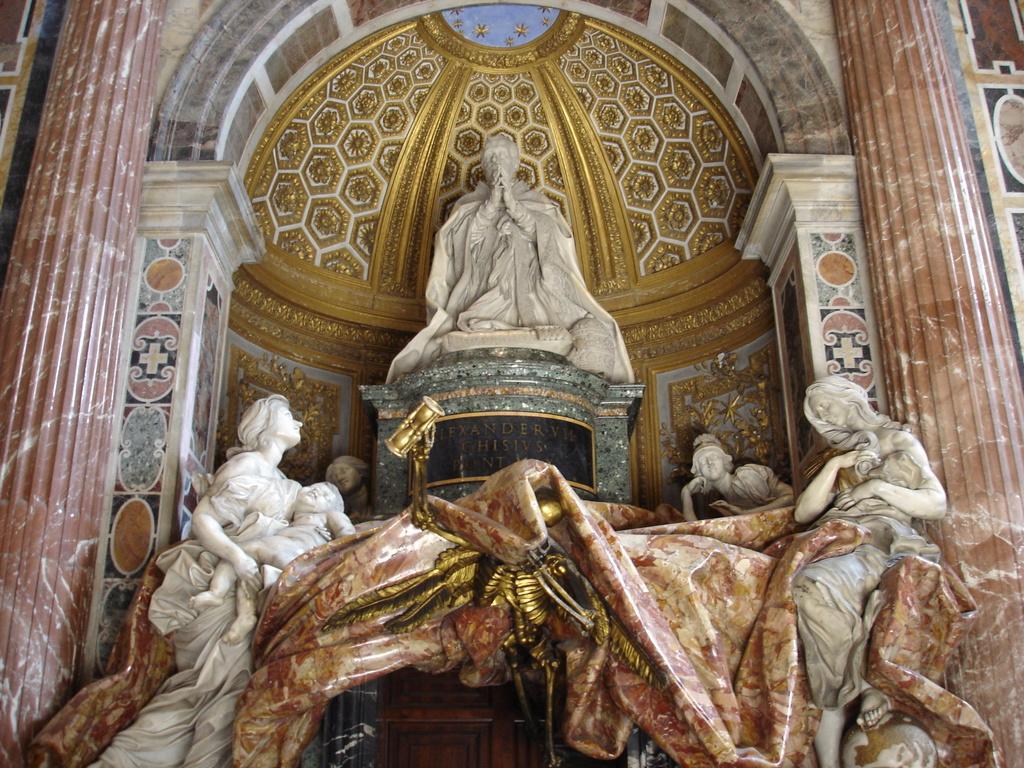Can you describe this image briefly? In this image there are statues, designed wall and objects. 